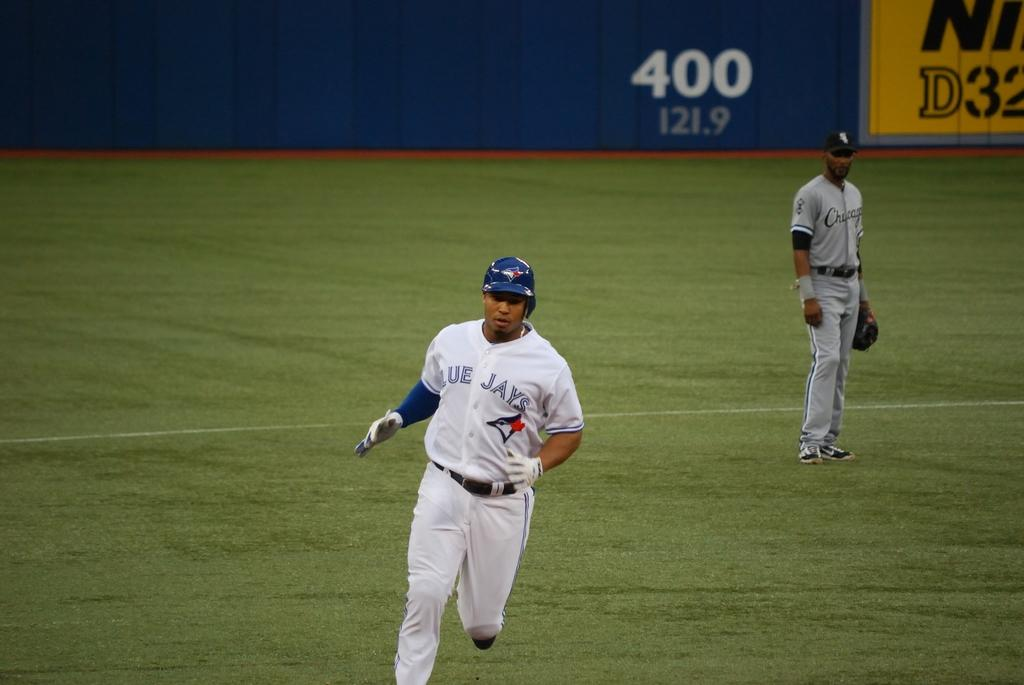<image>
Write a terse but informative summary of the picture. The number 400 can be seen behind a baseball field. 